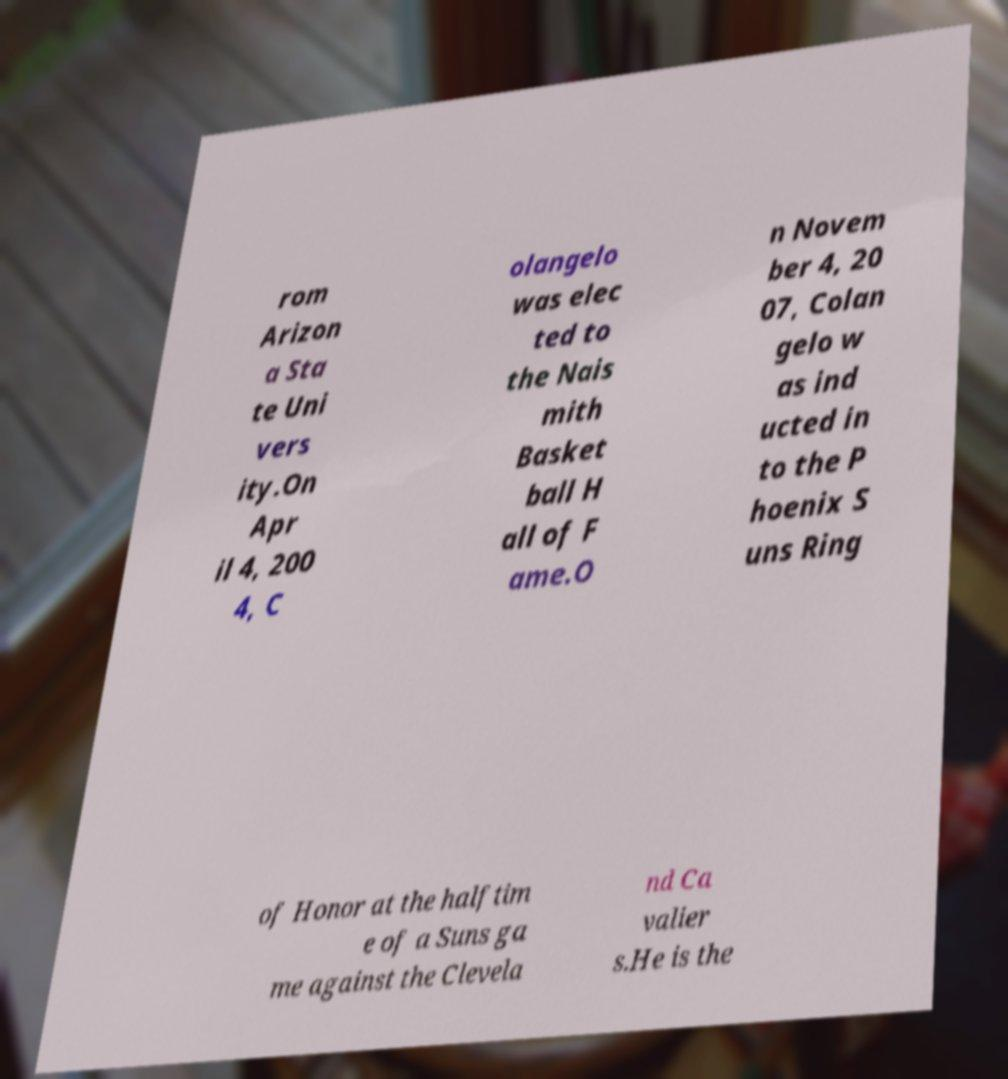Can you accurately transcribe the text from the provided image for me? rom Arizon a Sta te Uni vers ity.On Apr il 4, 200 4, C olangelo was elec ted to the Nais mith Basket ball H all of F ame.O n Novem ber 4, 20 07, Colan gelo w as ind ucted in to the P hoenix S uns Ring of Honor at the halftim e of a Suns ga me against the Clevela nd Ca valier s.He is the 